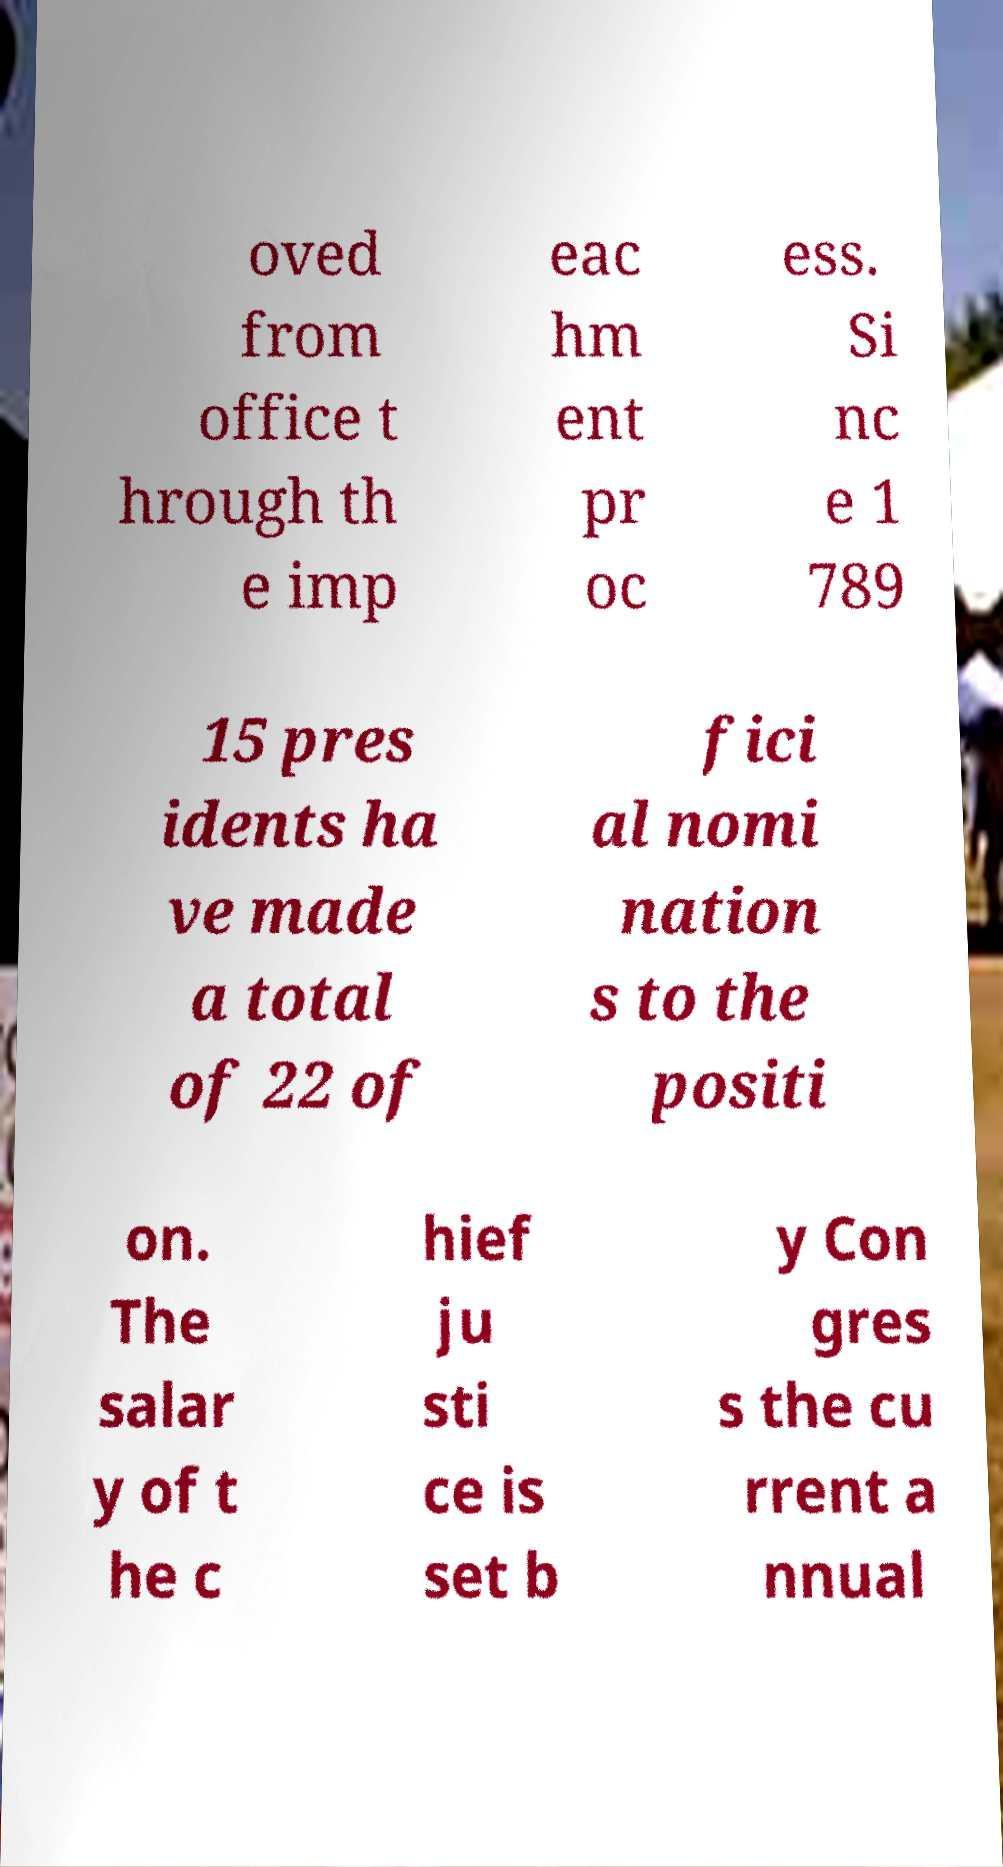Please identify and transcribe the text found in this image. oved from office t hrough th e imp eac hm ent pr oc ess. Si nc e 1 789 15 pres idents ha ve made a total of 22 of fici al nomi nation s to the positi on. The salar y of t he c hief ju sti ce is set b y Con gres s the cu rrent a nnual 